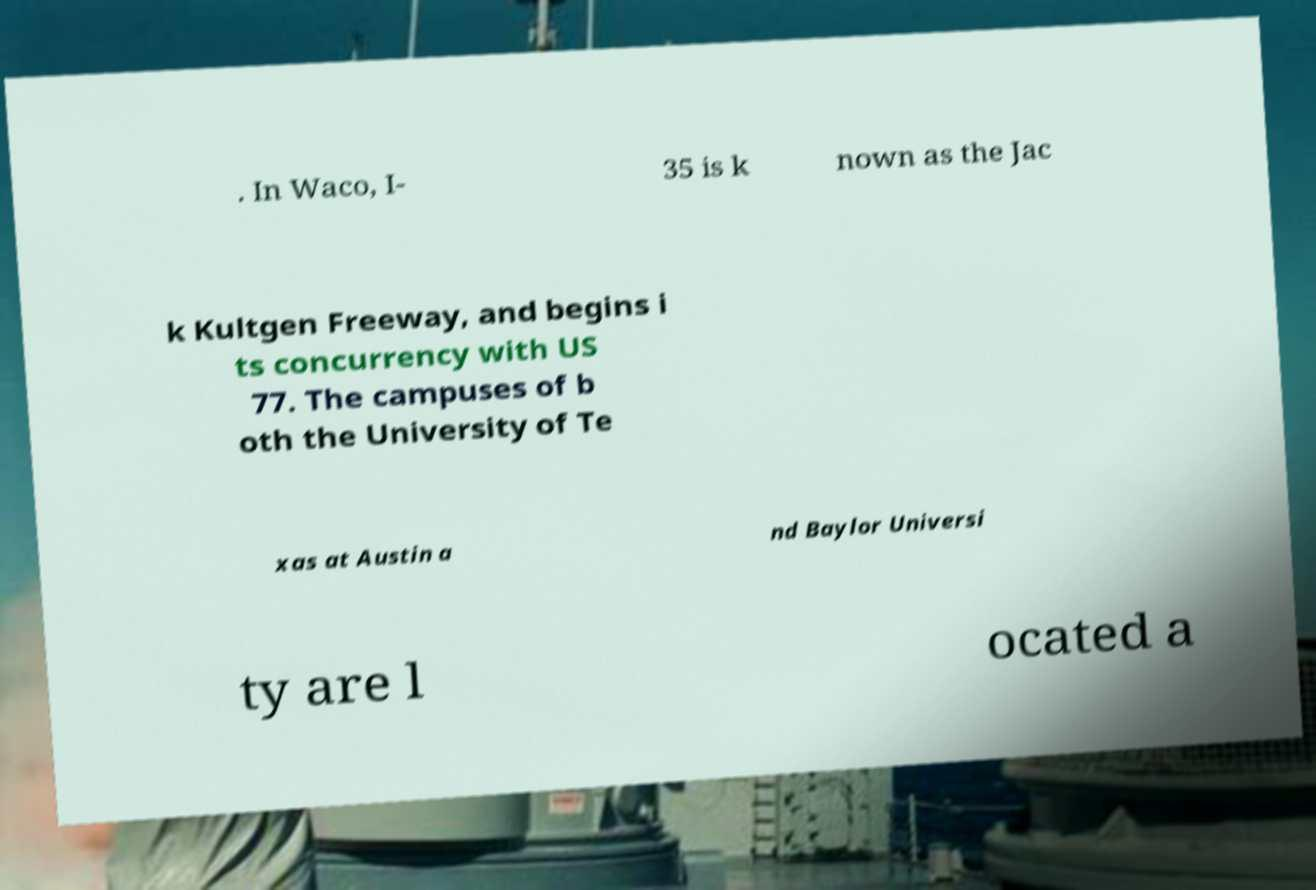For documentation purposes, I need the text within this image transcribed. Could you provide that? . In Waco, I- 35 is k nown as the Jac k Kultgen Freeway, and begins i ts concurrency with US 77. The campuses of b oth the University of Te xas at Austin a nd Baylor Universi ty are l ocated a 